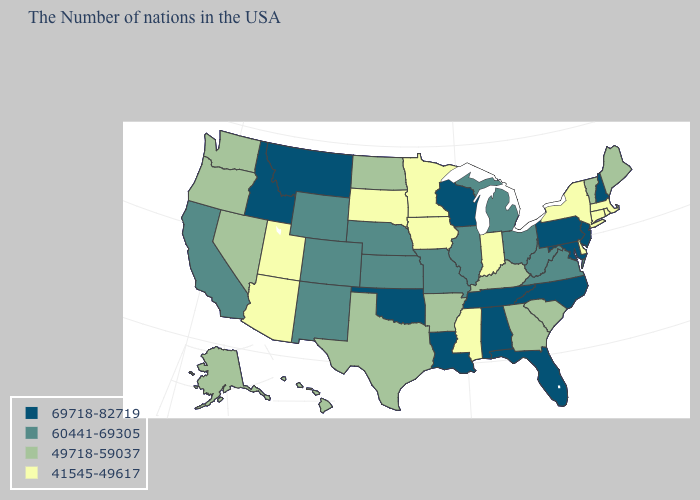What is the value of Connecticut?
Write a very short answer. 41545-49617. Name the states that have a value in the range 69718-82719?
Give a very brief answer. New Hampshire, New Jersey, Maryland, Pennsylvania, North Carolina, Florida, Alabama, Tennessee, Wisconsin, Louisiana, Oklahoma, Montana, Idaho. Which states have the lowest value in the MidWest?
Answer briefly. Indiana, Minnesota, Iowa, South Dakota. Does the first symbol in the legend represent the smallest category?
Answer briefly. No. What is the value of Texas?
Concise answer only. 49718-59037. What is the value of Massachusetts?
Keep it brief. 41545-49617. What is the value of New Hampshire?
Answer briefly. 69718-82719. Among the states that border Washington , does Idaho have the lowest value?
Be succinct. No. What is the value of Nebraska?
Concise answer only. 60441-69305. Name the states that have a value in the range 60441-69305?
Be succinct. Virginia, West Virginia, Ohio, Michigan, Illinois, Missouri, Kansas, Nebraska, Wyoming, Colorado, New Mexico, California. What is the lowest value in the USA?
Be succinct. 41545-49617. Which states have the highest value in the USA?
Quick response, please. New Hampshire, New Jersey, Maryland, Pennsylvania, North Carolina, Florida, Alabama, Tennessee, Wisconsin, Louisiana, Oklahoma, Montana, Idaho. Name the states that have a value in the range 49718-59037?
Concise answer only. Maine, Vermont, South Carolina, Georgia, Kentucky, Arkansas, Texas, North Dakota, Nevada, Washington, Oregon, Alaska, Hawaii. What is the value of Pennsylvania?
Quick response, please. 69718-82719. What is the highest value in states that border Idaho?
Answer briefly. 69718-82719. 